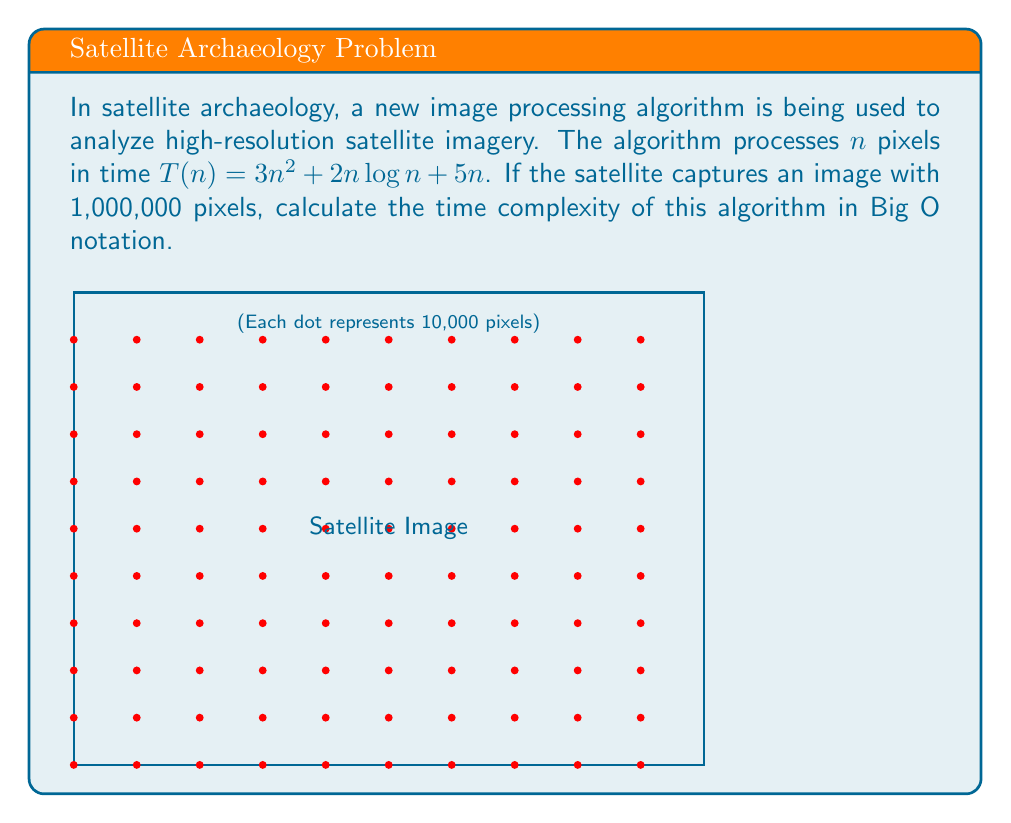Can you answer this question? To determine the time complexity in Big O notation, we need to identify the dominant term in the given time function $T(n) = 3n^2 + 2n\log n + 5n$ as $n$ approaches infinity.

Step 1: Identify the terms in the function
1. $3n^2$
2. $2n\log n$
3. $5n$

Step 2: Compare the growth rates of these terms
- $n^2$ grows faster than $n\log n$, which grows faster than $n$
- As $n$ becomes very large, $3n^2$ will dominate the other terms

Step 3: Apply the rules of Big O notation
- We can drop lower-order terms and constants
- $O(3n^2 + 2n\log n + 5n) = O(n^2)$

Step 4: Verify the result
- For $n = 1,000,000$:
  $3n^2 = 3 \times (10^6)^2 = 3 \times 10^{12}$
  $2n\log n \approx 2 \times 10^6 \times 20 = 4 \times 10^7$
  $5n = 5 \times 10^6$
- Clearly, $3n^2$ is the dominant term for large $n$

Therefore, the time complexity of this algorithm is $O(n^2)$.
Answer: $O(n^2)$ 